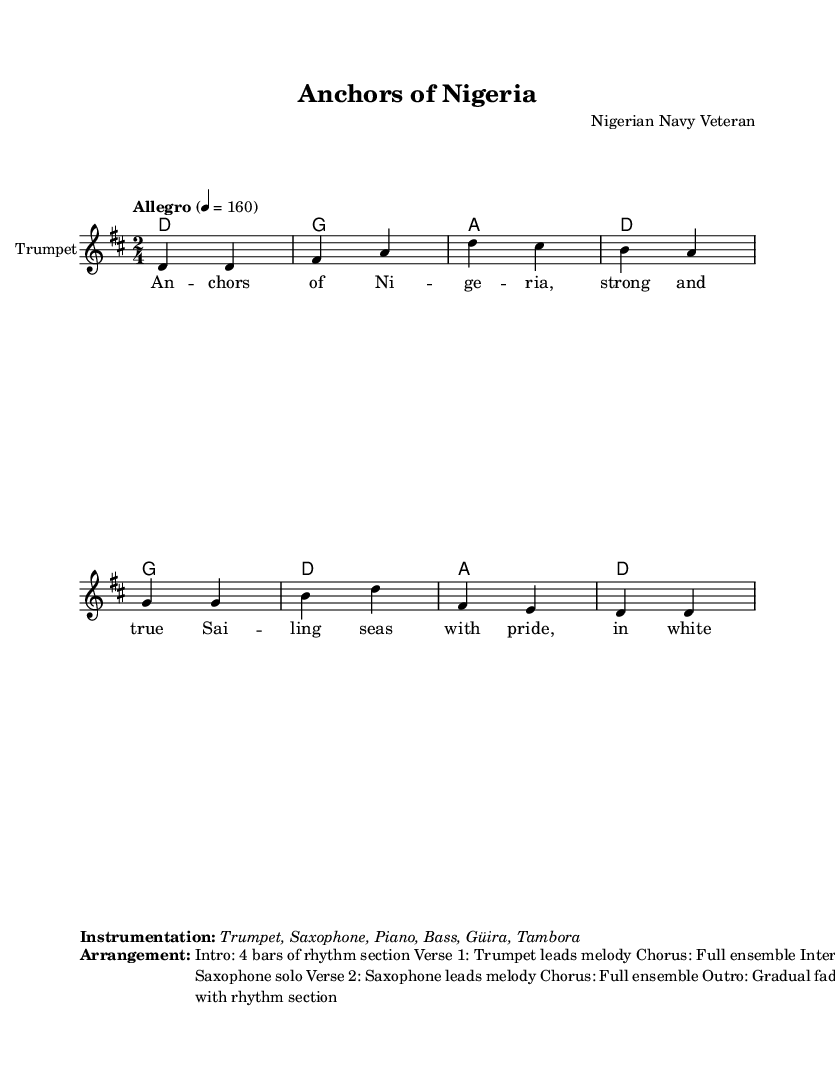What is the key signature of this music? The key signature is D major, which has two sharps (F# and C#). This can be determined by examining the global section where the key is indicated as 'd' for D major.
Answer: D major What is the time signature of this piece? The time signature is 2/4, which can be found in the global section where it is explicitly stated. This means there are two beats in each measure, and a quarter note receives one beat.
Answer: 2/4 What is the tempo marking of the music? The tempo marking is "Allegro," which indicates a fast tempo. This can be seen in the global section where it specifies a tempo of 4 = 160 beats per minute.
Answer: Allegro What instruments are used in this arrangement? The instrumentation includes Trumpet, Saxophone, Piano, Bass, Güira, and Tambora. This information is provided in the markup section that follows the score.
Answer: Trumpet, Saxophone, Piano, Bass, Güira, Tambora How many bars are in the intro? The intro consists of 4 bars, as stated in the arrangement section of the markup, where the structure begins with an "Intro: 4 bars of rhythm section."
Answer: 4 bars What leads the melody in the first verse? The melody in the first verse is led by the Trumpet. This is specified in the arrangement section of the markup where it mentions "Verse 1: Trumpet leads melody."
Answer: Trumpet What type of music is this piece classified as? This piece is classified as Merengue, a lively genre of Latin music characterized by its fast-paced rhythms. Given the patriotic and energetic themes reflected in the lyrics and instrumentation, it fits the features of Merengue music.
Answer: Merengue 